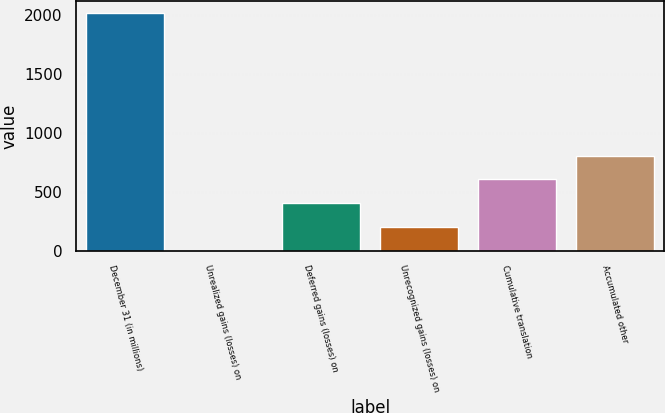<chart> <loc_0><loc_0><loc_500><loc_500><bar_chart><fcel>December 31 (in millions)<fcel>Unrealized gains (losses) on<fcel>Deferred gains (losses) on<fcel>Unrecognized gains (losses) on<fcel>Cumulative translation<fcel>Accumulated other<nl><fcel>2015<fcel>1<fcel>403.8<fcel>202.4<fcel>605.2<fcel>806.6<nl></chart> 